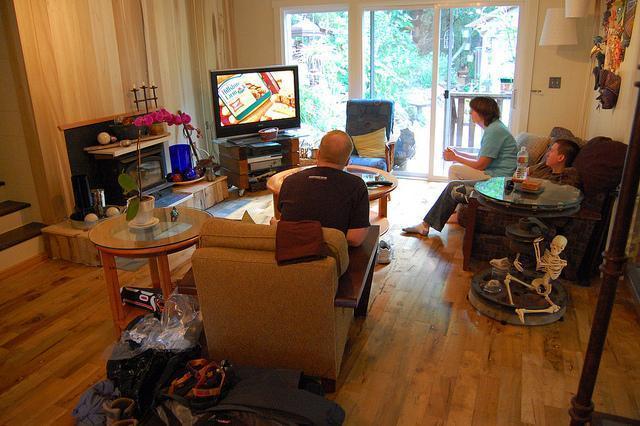How many tvs are there?
Give a very brief answer. 1. How many chairs are there?
Give a very brief answer. 2. How many people are there?
Give a very brief answer. 3. How many beds are here?
Give a very brief answer. 0. 